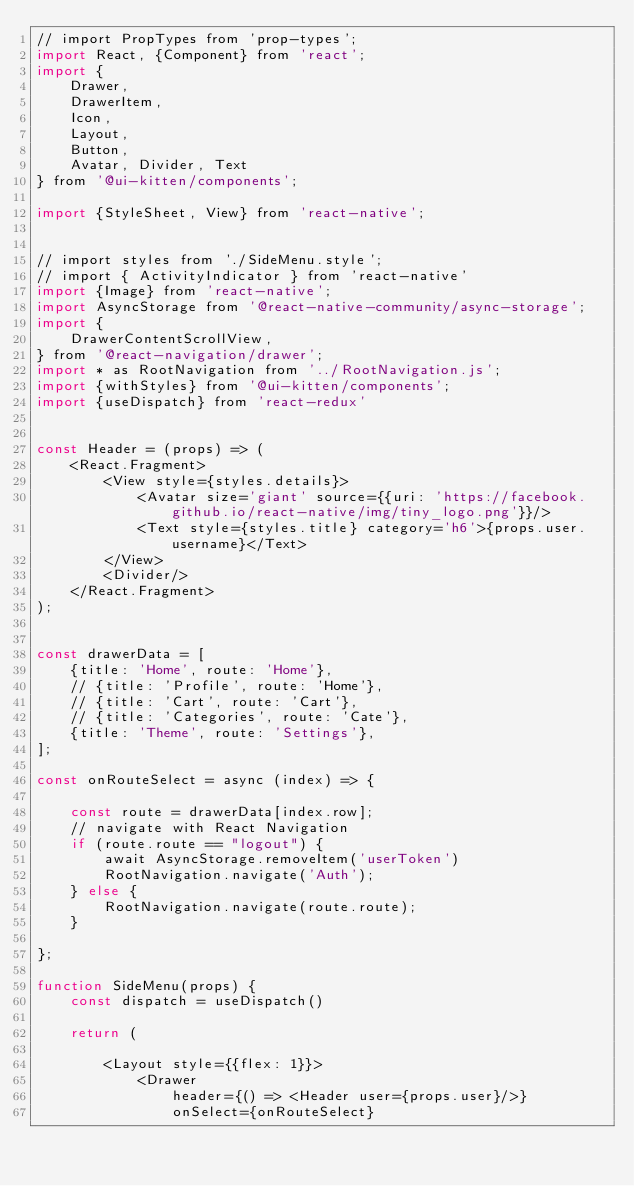Convert code to text. <code><loc_0><loc_0><loc_500><loc_500><_JavaScript_>// import PropTypes from 'prop-types';
import React, {Component} from 'react';
import {
    Drawer,
    DrawerItem,
    Icon,
    Layout,
    Button,
    Avatar, Divider, Text
} from '@ui-kitten/components';

import {StyleSheet, View} from 'react-native';


// import styles from './SideMenu.style';
// import { ActivityIndicator } from 'react-native'
import {Image} from 'react-native';
import AsyncStorage from '@react-native-community/async-storage';
import {
    DrawerContentScrollView,
} from '@react-navigation/drawer';
import * as RootNavigation from '../RootNavigation.js';
import {withStyles} from '@ui-kitten/components';
import {useDispatch} from 'react-redux'


const Header = (props) => (
    <React.Fragment>
        <View style={styles.details}>
            <Avatar size='giant' source={{uri: 'https://facebook.github.io/react-native/img/tiny_logo.png'}}/>
            <Text style={styles.title} category='h6'>{props.user.username}</Text>
        </View>
        <Divider/>
    </React.Fragment>
);


const drawerData = [
    {title: 'Home', route: 'Home'},
    // {title: 'Profile', route: 'Home'},
    // {title: 'Cart', route: 'Cart'},
    // {title: 'Categories', route: 'Cate'},
    {title: 'Theme', route: 'Settings'},
];

const onRouteSelect = async (index) => {

    const route = drawerData[index.row];
    // navigate with React Navigation
    if (route.route == "logout") {
        await AsyncStorage.removeItem('userToken')
        RootNavigation.navigate('Auth');
    } else {
        RootNavigation.navigate(route.route);
    }

};

function SideMenu(props) {
    const dispatch = useDispatch()

    return (

        <Layout style={{flex: 1}}>
            <Drawer
                header={() => <Header user={props.user}/>}
                onSelect={onRouteSelect}</code> 